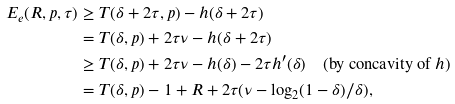Convert formula to latex. <formula><loc_0><loc_0><loc_500><loc_500>E _ { e } ( R , p , \tau ) & \geq T ( \delta + 2 \tau , p ) - h ( \delta + 2 \tau ) \\ & = T ( \delta , p ) + 2 \tau \nu - h ( \delta + 2 \tau ) \\ & \geq T ( \delta , p ) + 2 \tau \nu - h ( \delta ) - 2 \tau h ^ { \prime } ( \delta ) \quad ( \text {by concavity of } h ) \\ & = T ( \delta , p ) - 1 + R + 2 \tau ( \nu - \log _ { 2 } ( 1 - \delta ) / \delta ) ,</formula> 